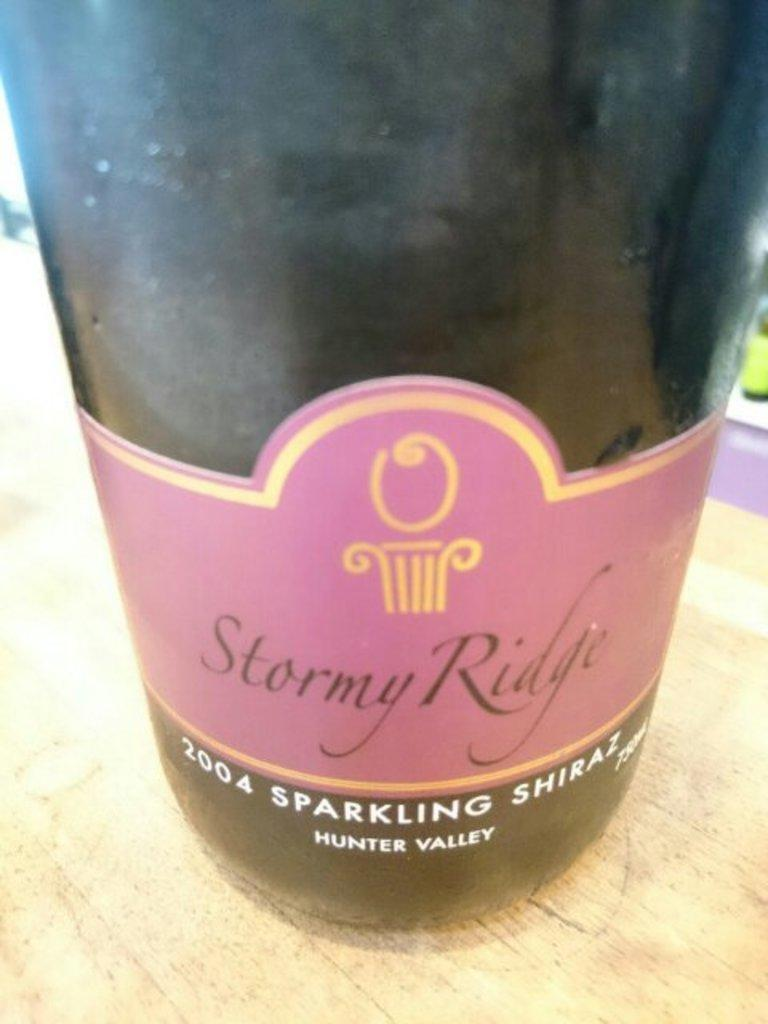<image>
Relay a brief, clear account of the picture shown. A 2004 bottle of sparkling shiraz branded Stormy ridge. 